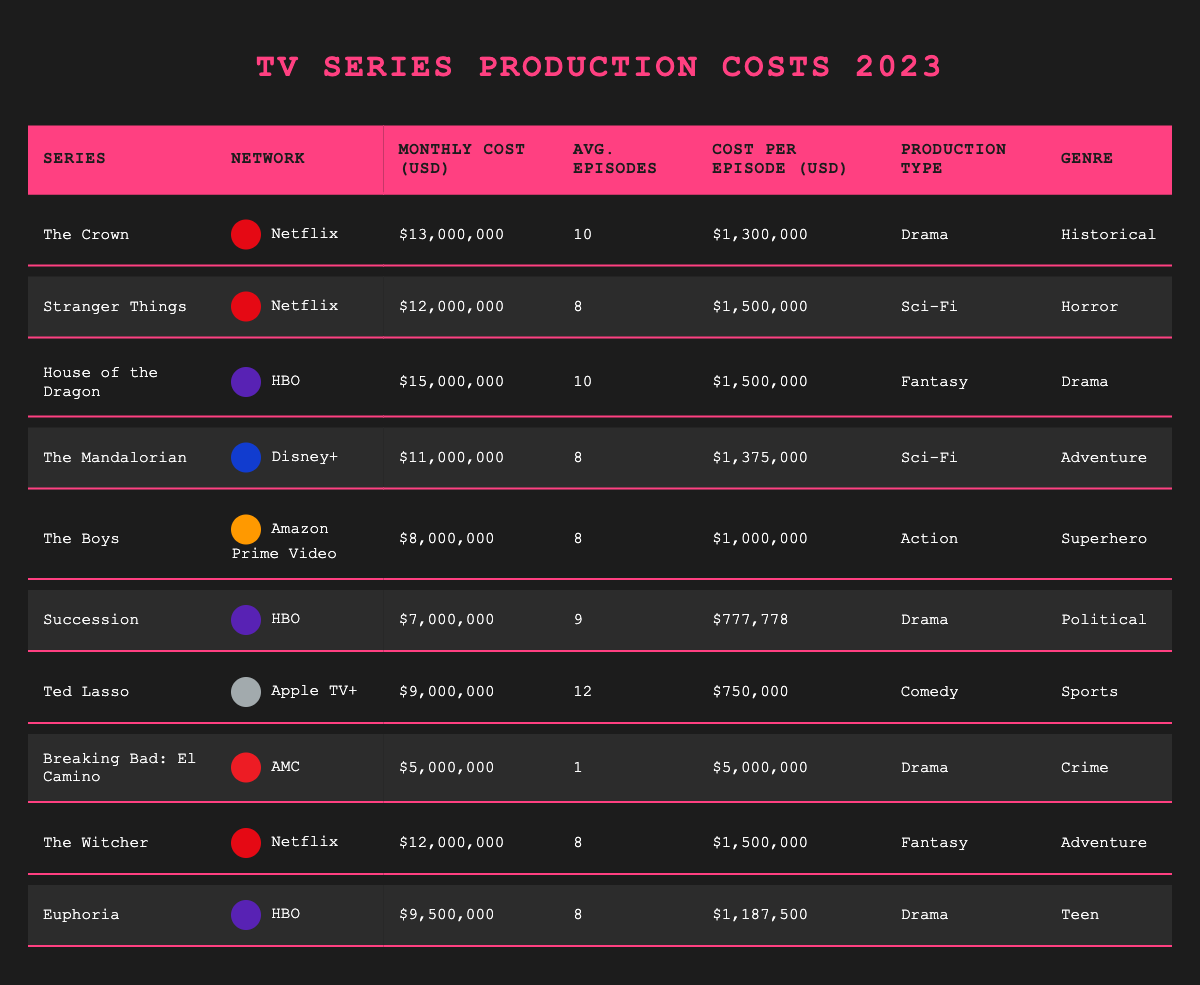What is the monthly production cost of "The Crown"? The table lists "The Crown" under the Series column and shows its Monthly Cost as $13,000,000.
Answer: $13,000,000 Which series has the highest cost per episode? Examining the Cost Per Episode column, "Breaking Bad: El Camino" shows a cost of $5,000,000 per episode, which is the highest among all listed series.
Answer: $5,000,000 What is the average monthly cost of shows aired on HBO? The monthly costs for HBO shows "House of the Dragon" ($15,000,000), "Succession" ($7,000,000), and "Euphoria" ($9,500,000) sum up to $31,500,000. There are three shows, so the average is $31,500,000 / 3 = $10,500,000.
Answer: $10,500,000 How many shows have a production type categorized as "Drama"? Counting rows under the Production Type column that specify "Drama," there are five series: "The Crown," "House of the Dragon," "Succession," "Euphoria," and "Breaking Bad: El Camino."
Answer: 5 What is the total monthly production cost for Netflix series? The Netflix series are "The Crown" ($13,000,000), "Stranger Things" ($12,000,000), and "The Witcher" ($12,000,000). Adding these amounts gives $13,000,000 + $12,000,000 + $12,000,000 = $37,000,000.
Answer: $37,000,000 Which genre has the lowest average cost per episode? The genres and their costs per episode are: "Historical" ($1,300,000), "Horror" ($1,500,000), "Drama" ($1,500,000), "Adventure" ($1,375,000), "Superhero" ($1,000,000), "Political" ($777,778), "Sports" ($750,000), "Crime" ($5,000,000), "Teen" ($1,187,500). The lowest is "Political" with $777,778.
Answer: Political Does "The Mandalorian" have a higher monthly cost than "The Boys"? "The Mandalorian" has a monthly cost of $11,000,000 while "The Boys" has $8,000,000. Since $11,000,000 is greater than $8,000,000, the statement is true.
Answer: Yes What is the difference in monthly production costs between the most expensive and least expensive series? The most expensive series is "House of the Dragon" at $15,000,000, and the least expensive is "Breaking Bad: El Camino" at $5,000,000. The difference is $15,000,000 - $5,000,000 = $10,000,000.
Answer: $10,000,000 How many series have a monthly production cost of less than $10 million? The series with costs below $10 million are "The Boys" ($8,000,000), "Succession" ($7,000,000), and "Ted Lasso" ($9,000,000), totaling three series.
Answer: 3 What is the average number of episodes for all series listed? The average is calculated as follows: sum of average episodes (10 + 8 + 10 + 8 + 8 + 9 + 12 + 1 + 8 + 8) = 82 episodes. With 10 series, the average is 82 / 10 = 8.2.
Answer: 8.2 Which show has the least number of average episodes, and what is that number? Analyzing the Average Episodes column, "Breaking Bad: El Camino" has only 1 average episode, which is the least among all shows.
Answer: 1 